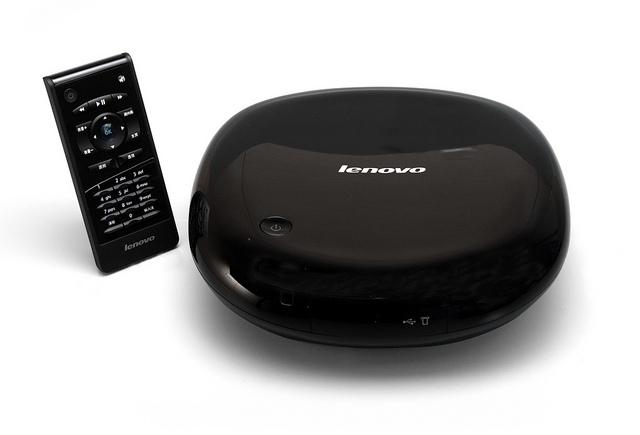What is the name of the device?
Concise answer only. Lenovo. Can you stream videos with this device?
Give a very brief answer. Yes. Could you make phone calls with this device?
Keep it brief. No. 